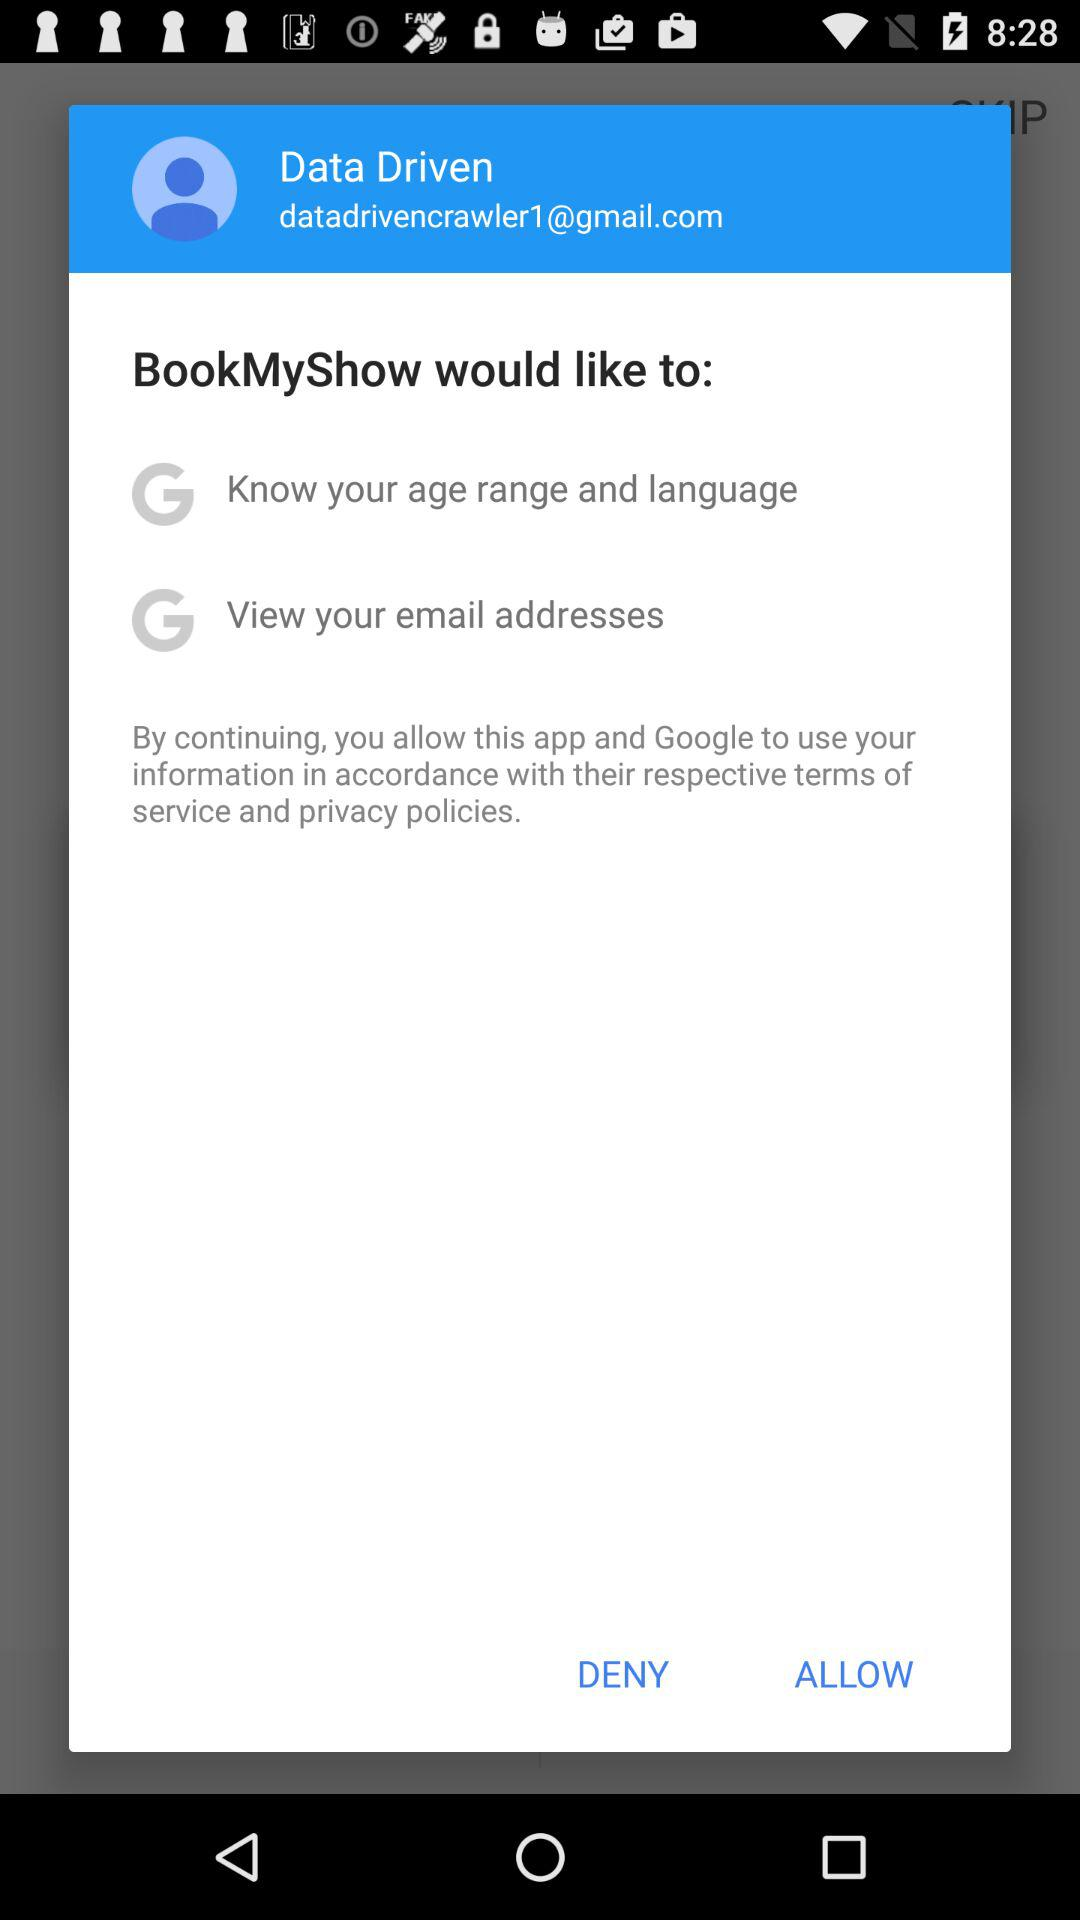What is the email address of the user? The email address of the user is datadrivencrawler1@gmail.com. 